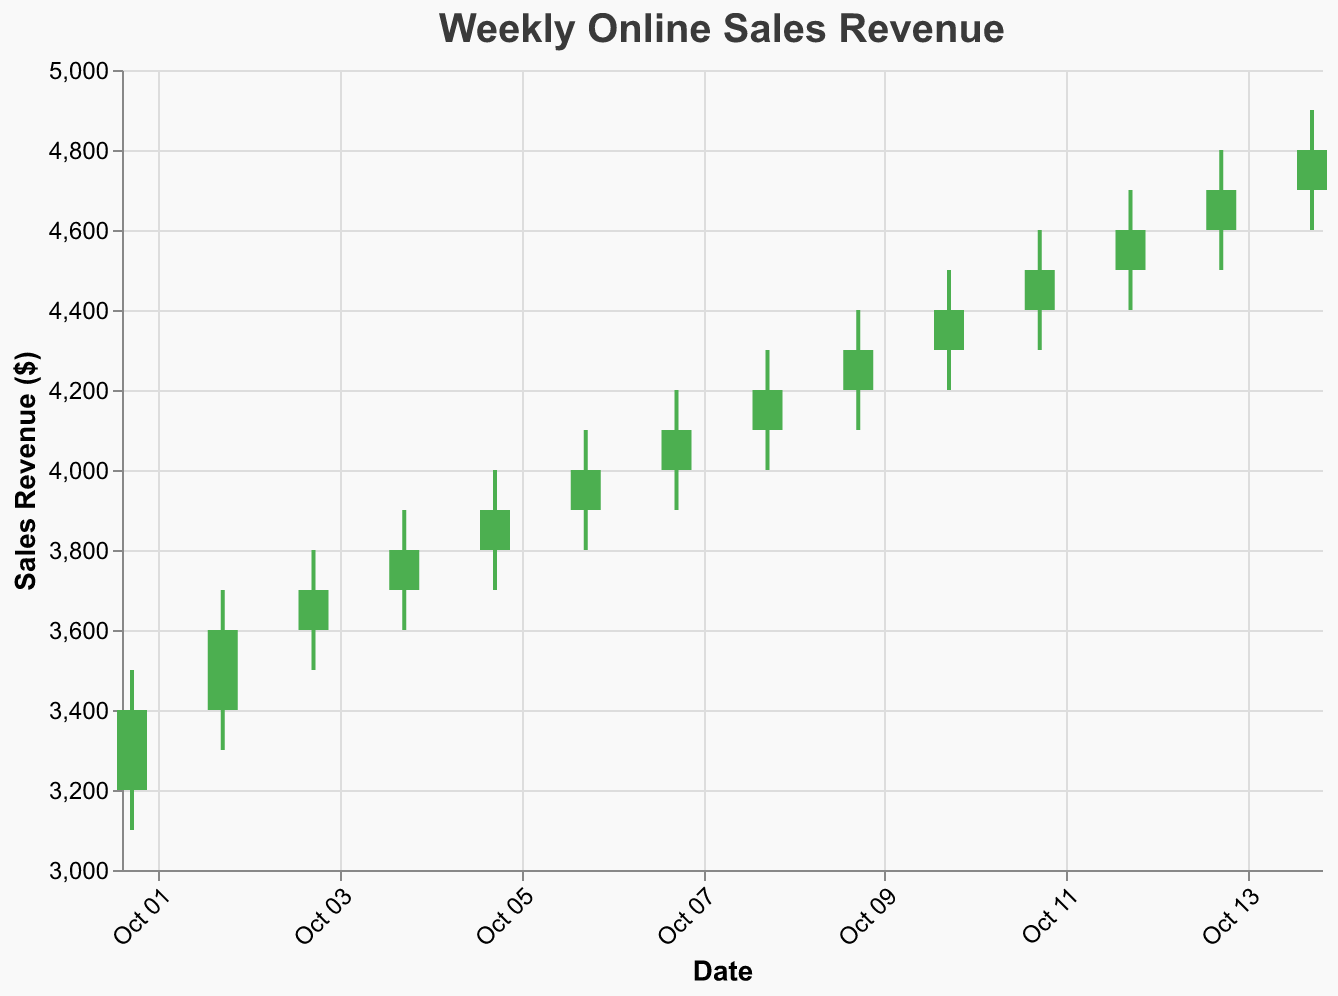What is the title of the figure? The title of the figure is typically placed at the top of the plot and reads as "Weekly Online Sales Revenue".
Answer: Weekly Online Sales Revenue On which date was the highest selling point recorded, and what was that number? The highest selling point corresponds to the peak of the "High" value on the candlestick plot. The highest "High" value across the data is 4900, recorded on October 14, 2023.
Answer: October 14, 2023, 4900 Was there any day when the sales revenue closed lower than it opened? You need to compare the "Open" and "Close" values for each day. If the "Close" value is lower than the "Open" value, the answer is yes. Based on the data, every day has the "Close" value higher than the "Open" value.
Answer: No How did the sales revenue change from Monday to Friday in the first week of October? Compare the "Open" value on October 2, 2023, and the "Close" value on October 6, 2023. On October 2 (Monday), the "Open" value is 3400, and on October 6 (Friday), the "Close" value is 4000. The change can be calculated as 4000 - 3400.
Answer: Increased by 600 What was the average sales revenue close value for the second week of October? The second week consists of days from October 8 to October 14. The average "Close" value is calculated by summing the "Close" values and dividing by the number of days: (4200 + 4300 + 4400 + 4500 + 4600 + 4700 + 4800) / 7.
Answer: 4500 Which weekday typically had higher revenue: Monday or Friday? Compare the values of "High" for Mondays and Fridays from the given data. The highest values for Monday (October 2 and October 9) are 3700 and 4400, and for Friday (October 6 and October 13) are 4100 and 4800. Fridays generally show higher values overall.
Answer: Friday Which day shows the largest difference between the "High" and "Low" points? Calculate the difference between the "High" and "Low" for each day and determine the largest. For example, on October 14, the difference is 4900 - 4600 = 300, which is the highest among all days.
Answer: October 14, 300 By how much did the sales revenue increase from the opening value on October 1, 2023, to the closing value on October 14, 2023? Subtract the "Open" value on October 1 (3200) from the "Close" value on October 14 (4800). The difference is 4800 - 3200.
Answer: 1600 